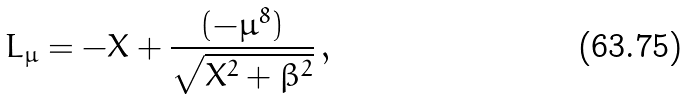<formula> <loc_0><loc_0><loc_500><loc_500>L _ { \mu } = - X + \frac { ( - \mu ^ { 8 } ) } { \sqrt { X ^ { 2 } + \beta ^ { 2 } } } \, ,</formula> 